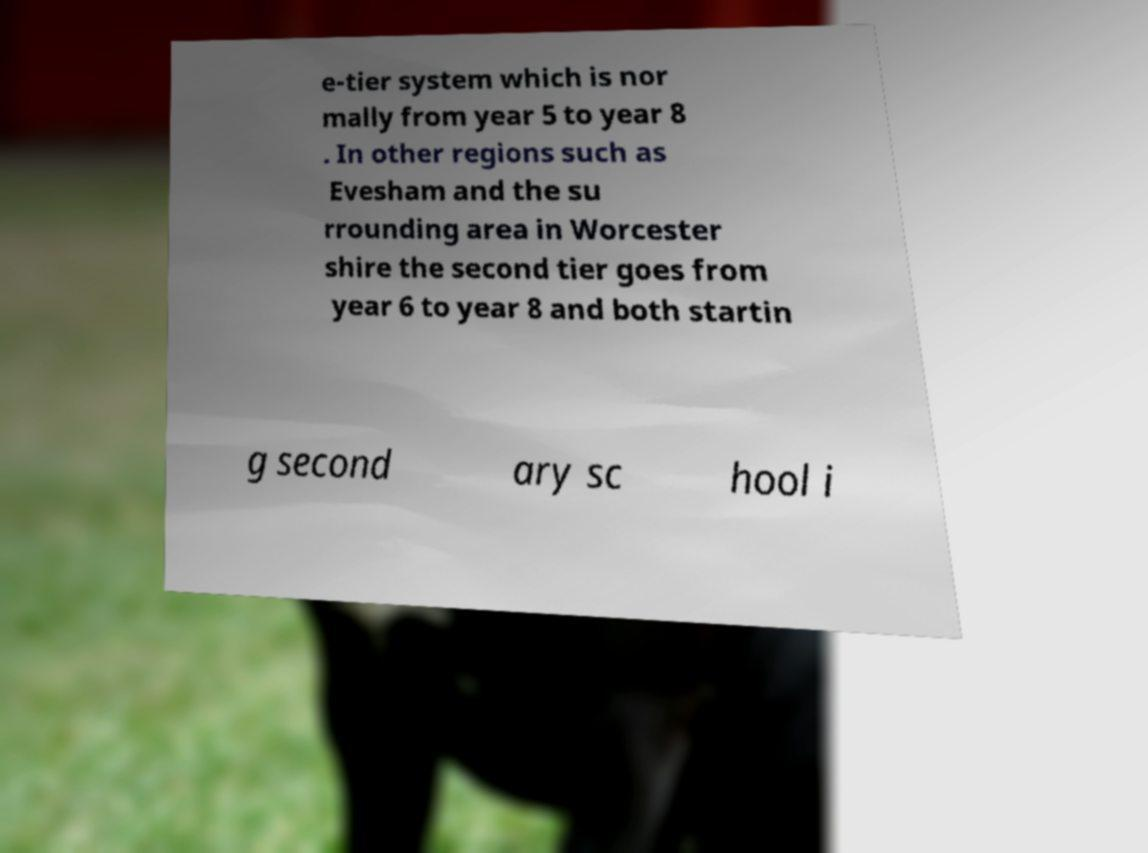There's text embedded in this image that I need extracted. Can you transcribe it verbatim? e-tier system which is nor mally from year 5 to year 8 . In other regions such as Evesham and the su rrounding area in Worcester shire the second tier goes from year 6 to year 8 and both startin g second ary sc hool i 